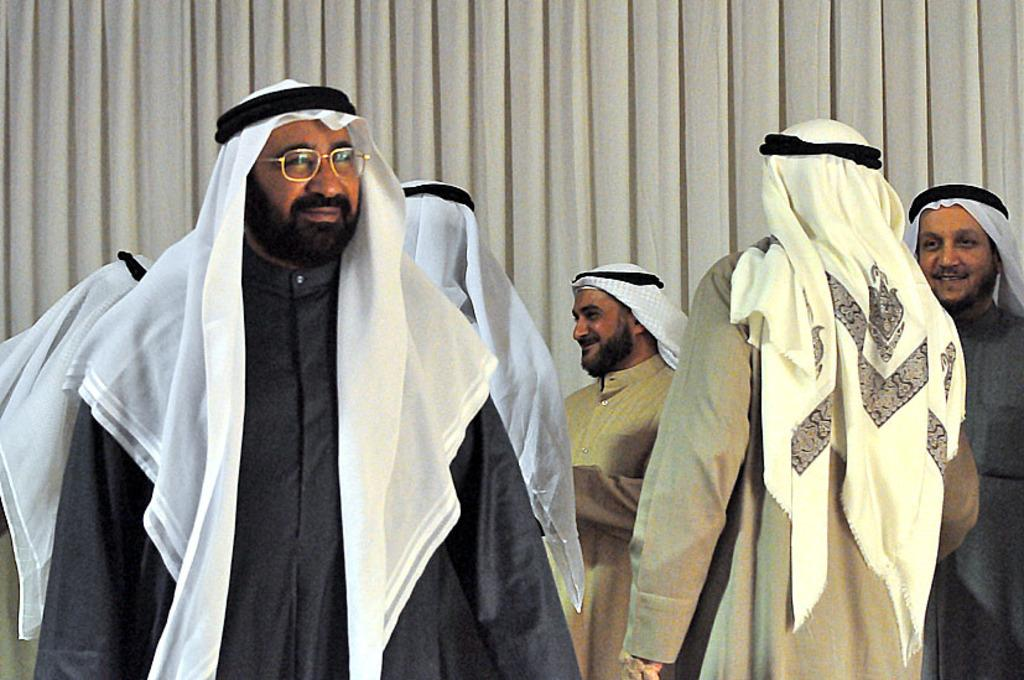What is happening in the image? There is a group of people in the image, and they are standing and smiling. Can you describe the background of the image? There is a cream-colored curtain in the background of the image. What type of vegetable is being used as a prop in the image? There is no vegetable present in the image; it features a group of people standing and smiling. 